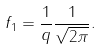Convert formula to latex. <formula><loc_0><loc_0><loc_500><loc_500>f _ { 1 } = \frac { 1 } { q } \frac { 1 } { \sqrt { 2 \pi } } .</formula> 